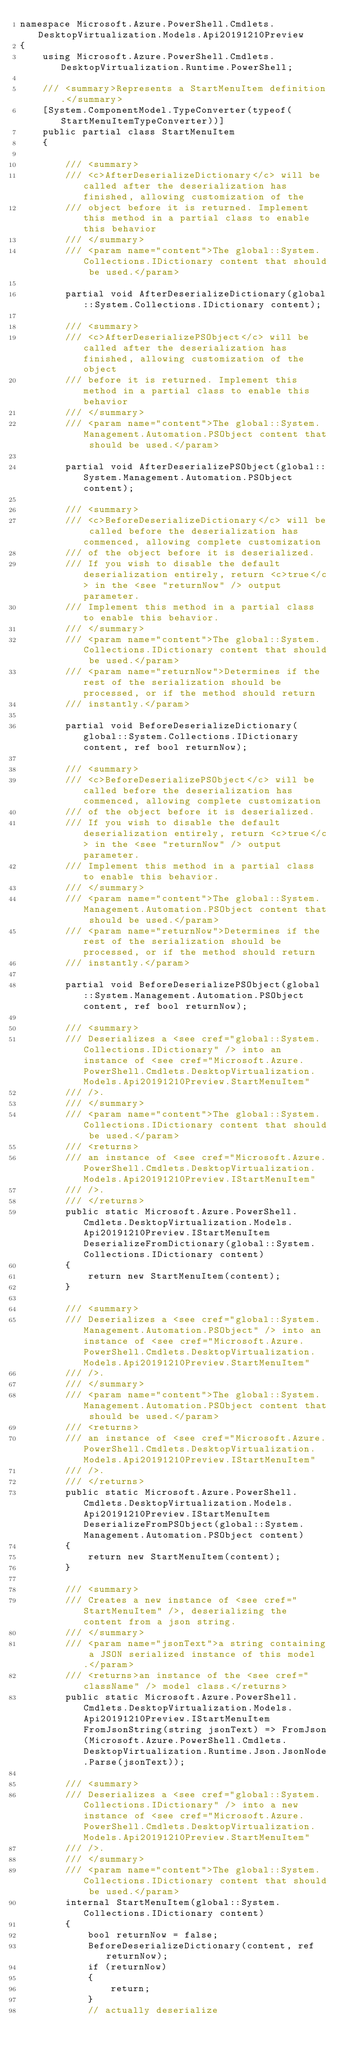Convert code to text. <code><loc_0><loc_0><loc_500><loc_500><_C#_>namespace Microsoft.Azure.PowerShell.Cmdlets.DesktopVirtualization.Models.Api20191210Preview
{
    using Microsoft.Azure.PowerShell.Cmdlets.DesktopVirtualization.Runtime.PowerShell;

    /// <summary>Represents a StartMenuItem definition.</summary>
    [System.ComponentModel.TypeConverter(typeof(StartMenuItemTypeConverter))]
    public partial class StartMenuItem
    {

        /// <summary>
        /// <c>AfterDeserializeDictionary</c> will be called after the deserialization has finished, allowing customization of the
        /// object before it is returned. Implement this method in a partial class to enable this behavior
        /// </summary>
        /// <param name="content">The global::System.Collections.IDictionary content that should be used.</param>

        partial void AfterDeserializeDictionary(global::System.Collections.IDictionary content);

        /// <summary>
        /// <c>AfterDeserializePSObject</c> will be called after the deserialization has finished, allowing customization of the object
        /// before it is returned. Implement this method in a partial class to enable this behavior
        /// </summary>
        /// <param name="content">The global::System.Management.Automation.PSObject content that should be used.</param>

        partial void AfterDeserializePSObject(global::System.Management.Automation.PSObject content);

        /// <summary>
        /// <c>BeforeDeserializeDictionary</c> will be called before the deserialization has commenced, allowing complete customization
        /// of the object before it is deserialized.
        /// If you wish to disable the default deserialization entirely, return <c>true</c> in the <see "returnNow" /> output parameter.
        /// Implement this method in a partial class to enable this behavior.
        /// </summary>
        /// <param name="content">The global::System.Collections.IDictionary content that should be used.</param>
        /// <param name="returnNow">Determines if the rest of the serialization should be processed, or if the method should return
        /// instantly.</param>

        partial void BeforeDeserializeDictionary(global::System.Collections.IDictionary content, ref bool returnNow);

        /// <summary>
        /// <c>BeforeDeserializePSObject</c> will be called before the deserialization has commenced, allowing complete customization
        /// of the object before it is deserialized.
        /// If you wish to disable the default deserialization entirely, return <c>true</c> in the <see "returnNow" /> output parameter.
        /// Implement this method in a partial class to enable this behavior.
        /// </summary>
        /// <param name="content">The global::System.Management.Automation.PSObject content that should be used.</param>
        /// <param name="returnNow">Determines if the rest of the serialization should be processed, or if the method should return
        /// instantly.</param>

        partial void BeforeDeserializePSObject(global::System.Management.Automation.PSObject content, ref bool returnNow);

        /// <summary>
        /// Deserializes a <see cref="global::System.Collections.IDictionary" /> into an instance of <see cref="Microsoft.Azure.PowerShell.Cmdlets.DesktopVirtualization.Models.Api20191210Preview.StartMenuItem"
        /// />.
        /// </summary>
        /// <param name="content">The global::System.Collections.IDictionary content that should be used.</param>
        /// <returns>
        /// an instance of <see cref="Microsoft.Azure.PowerShell.Cmdlets.DesktopVirtualization.Models.Api20191210Preview.IStartMenuItem"
        /// />.
        /// </returns>
        public static Microsoft.Azure.PowerShell.Cmdlets.DesktopVirtualization.Models.Api20191210Preview.IStartMenuItem DeserializeFromDictionary(global::System.Collections.IDictionary content)
        {
            return new StartMenuItem(content);
        }

        /// <summary>
        /// Deserializes a <see cref="global::System.Management.Automation.PSObject" /> into an instance of <see cref="Microsoft.Azure.PowerShell.Cmdlets.DesktopVirtualization.Models.Api20191210Preview.StartMenuItem"
        /// />.
        /// </summary>
        /// <param name="content">The global::System.Management.Automation.PSObject content that should be used.</param>
        /// <returns>
        /// an instance of <see cref="Microsoft.Azure.PowerShell.Cmdlets.DesktopVirtualization.Models.Api20191210Preview.IStartMenuItem"
        /// />.
        /// </returns>
        public static Microsoft.Azure.PowerShell.Cmdlets.DesktopVirtualization.Models.Api20191210Preview.IStartMenuItem DeserializeFromPSObject(global::System.Management.Automation.PSObject content)
        {
            return new StartMenuItem(content);
        }

        /// <summary>
        /// Creates a new instance of <see cref="StartMenuItem" />, deserializing the content from a json string.
        /// </summary>
        /// <param name="jsonText">a string containing a JSON serialized instance of this model.</param>
        /// <returns>an instance of the <see cref="className" /> model class.</returns>
        public static Microsoft.Azure.PowerShell.Cmdlets.DesktopVirtualization.Models.Api20191210Preview.IStartMenuItem FromJsonString(string jsonText) => FromJson(Microsoft.Azure.PowerShell.Cmdlets.DesktopVirtualization.Runtime.Json.JsonNode.Parse(jsonText));

        /// <summary>
        /// Deserializes a <see cref="global::System.Collections.IDictionary" /> into a new instance of <see cref="Microsoft.Azure.PowerShell.Cmdlets.DesktopVirtualization.Models.Api20191210Preview.StartMenuItem"
        /// />.
        /// </summary>
        /// <param name="content">The global::System.Collections.IDictionary content that should be used.</param>
        internal StartMenuItem(global::System.Collections.IDictionary content)
        {
            bool returnNow = false;
            BeforeDeserializeDictionary(content, ref returnNow);
            if (returnNow)
            {
                return;
            }
            // actually deserialize</code> 